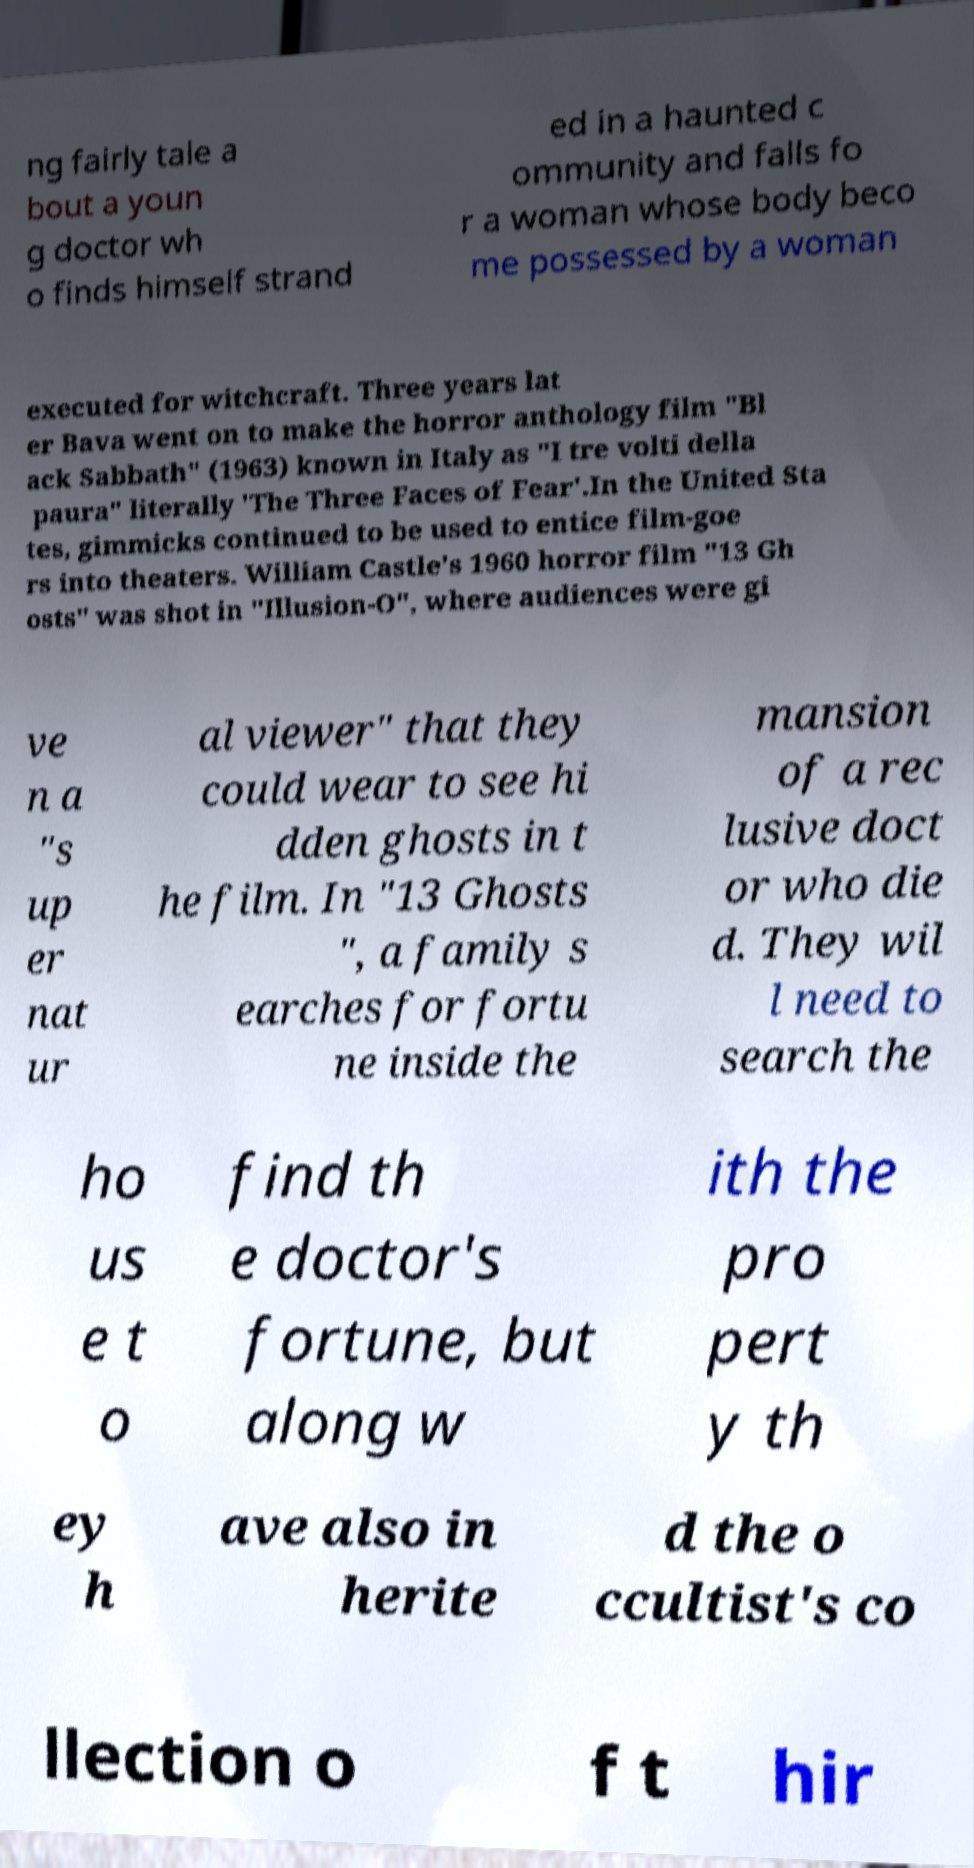Could you extract and type out the text from this image? ng fairly tale a bout a youn g doctor wh o finds himself strand ed in a haunted c ommunity and falls fo r a woman whose body beco me possessed by a woman executed for witchcraft. Three years lat er Bava went on to make the horror anthology film "Bl ack Sabbath" (1963) known in Italy as "I tre volti della paura" literally 'The Three Faces of Fear'.In the United Sta tes, gimmicks continued to be used to entice film-goe rs into theaters. William Castle's 1960 horror film "13 Gh osts" was shot in "Illusion-O", where audiences were gi ve n a "s up er nat ur al viewer" that they could wear to see hi dden ghosts in t he film. In "13 Ghosts ", a family s earches for fortu ne inside the mansion of a rec lusive doct or who die d. They wil l need to search the ho us e t o find th e doctor's fortune, but along w ith the pro pert y th ey h ave also in herite d the o ccultist's co llection o f t hir 